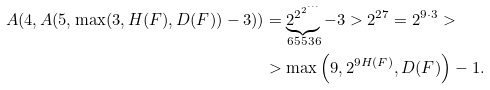<formula> <loc_0><loc_0><loc_500><loc_500>A ( 4 , A ( 5 , \max ( 3 , H ( F ) , D ( F ) ) - 3 ) ) & = \underbrace { 2 ^ { 2 ^ { 2 ^ { \cdots } } } } _ { 6 5 5 3 6 } - 3 > 2 ^ { 2 7 } = 2 ^ { 9 \cdot 3 } > \\ & > \max \left ( 9 , 2 ^ { 9 H ( F ) } , D ( F ) \right ) - 1 .</formula> 